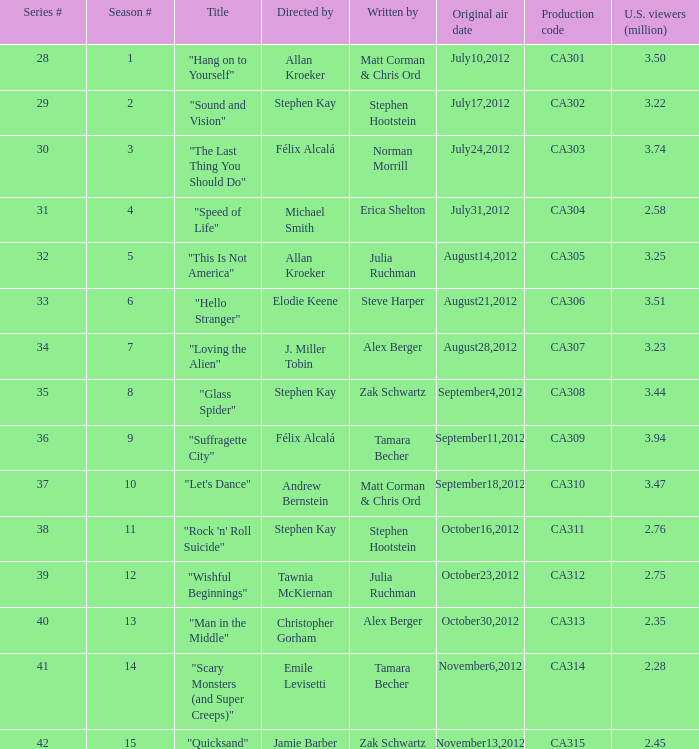Would you mind parsing the complete table? {'header': ['Series #', 'Season #', 'Title', 'Directed by', 'Written by', 'Original air date', 'Production code', 'U.S. viewers (million)'], 'rows': [['28', '1', '"Hang on to Yourself"', 'Allan Kroeker', 'Matt Corman & Chris Ord', 'July10,2012', 'CA301', '3.50'], ['29', '2', '"Sound and Vision"', 'Stephen Kay', 'Stephen Hootstein', 'July17,2012', 'CA302', '3.22'], ['30', '3', '"The Last Thing You Should Do"', 'Félix Alcalá', 'Norman Morrill', 'July24,2012', 'CA303', '3.74'], ['31', '4', '"Speed of Life"', 'Michael Smith', 'Erica Shelton', 'July31,2012', 'CA304', '2.58'], ['32', '5', '"This Is Not America"', 'Allan Kroeker', 'Julia Ruchman', 'August14,2012', 'CA305', '3.25'], ['33', '6', '"Hello Stranger"', 'Elodie Keene', 'Steve Harper', 'August21,2012', 'CA306', '3.51'], ['34', '7', '"Loving the Alien"', 'J. Miller Tobin', 'Alex Berger', 'August28,2012', 'CA307', '3.23'], ['35', '8', '"Glass Spider"', 'Stephen Kay', 'Zak Schwartz', 'September4,2012', 'CA308', '3.44'], ['36', '9', '"Suffragette City"', 'Félix Alcalá', 'Tamara Becher', 'September11,2012', 'CA309', '3.94'], ['37', '10', '"Let\'s Dance"', 'Andrew Bernstein', 'Matt Corman & Chris Ord', 'September18,2012', 'CA310', '3.47'], ['38', '11', '"Rock \'n\' Roll Suicide"', 'Stephen Kay', 'Stephen Hootstein', 'October16,2012', 'CA311', '2.76'], ['39', '12', '"Wishful Beginnings"', 'Tawnia McKiernan', 'Julia Ruchman', 'October23,2012', 'CA312', '2.75'], ['40', '13', '"Man in the Middle"', 'Christopher Gorham', 'Alex Berger', 'October30,2012', 'CA313', '2.35'], ['41', '14', '"Scary Monsters (and Super Creeps)"', 'Emile Levisetti', 'Tamara Becher', 'November6,2012', 'CA314', '2.28'], ['42', '15', '"Quicksand"', 'Jamie Barber', 'Zak Schwartz', 'November13,2012', 'CA315', '2.45']]} Who directed the episode with production code ca303? Félix Alcalá. 